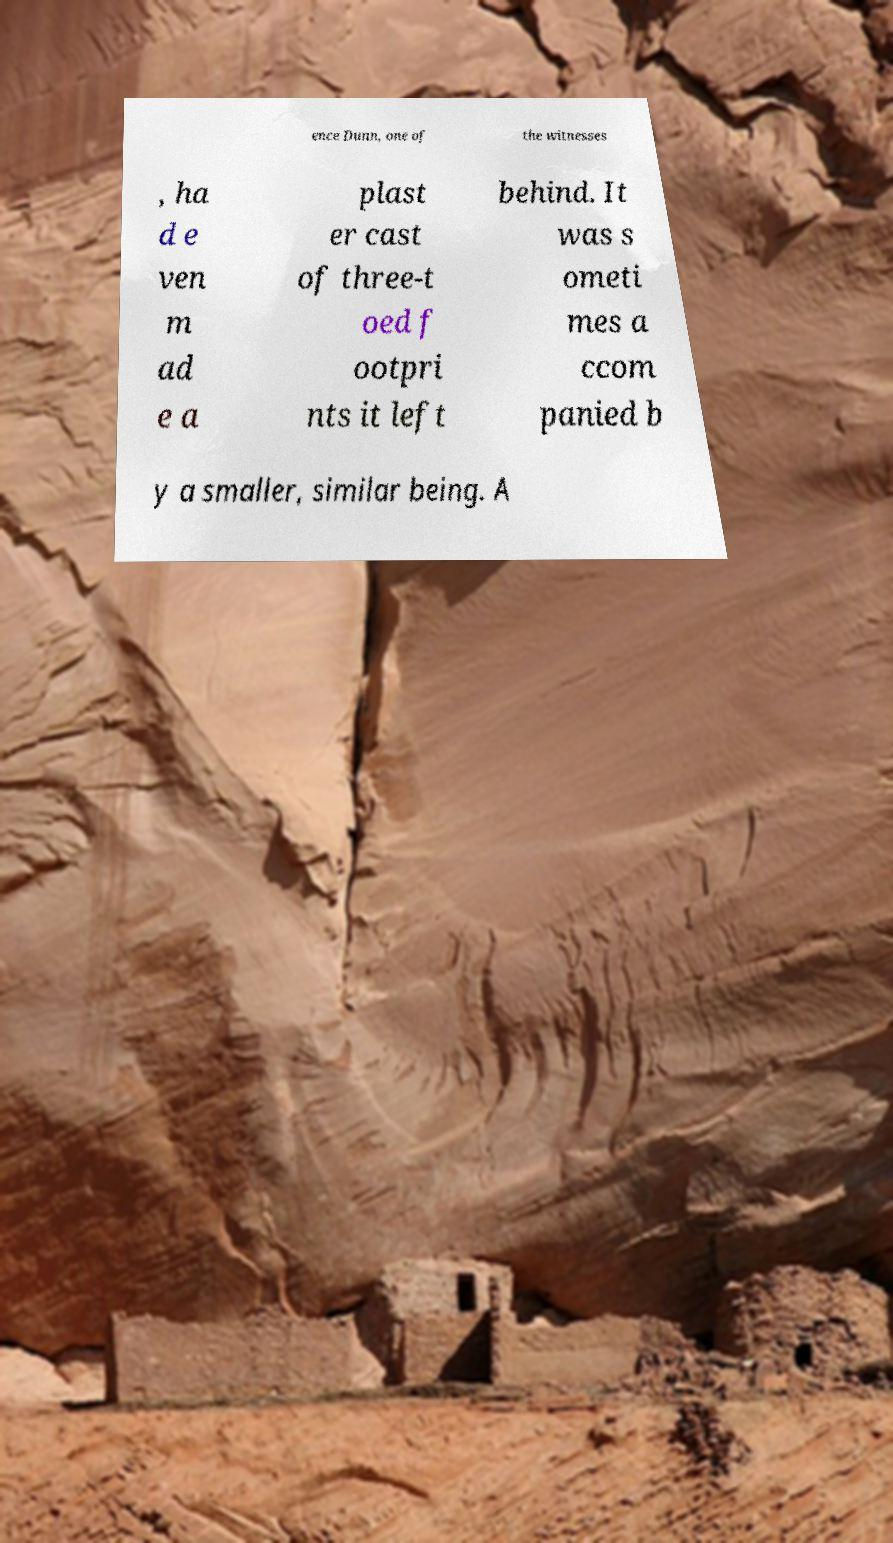Could you assist in decoding the text presented in this image and type it out clearly? ence Dunn, one of the witnesses , ha d e ven m ad e a plast er cast of three-t oed f ootpri nts it left behind. It was s ometi mes a ccom panied b y a smaller, similar being. A 